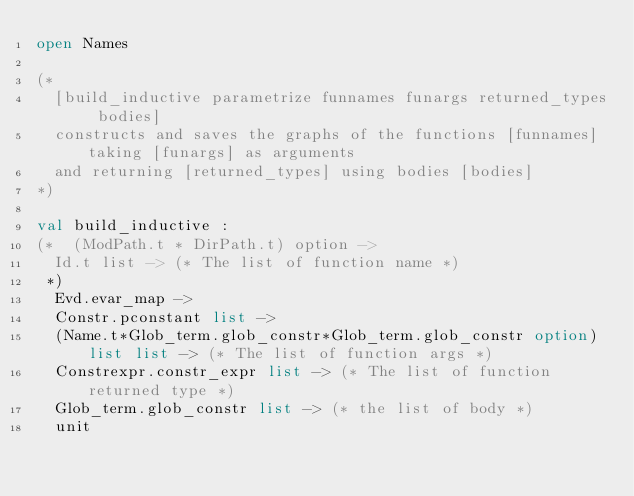<code> <loc_0><loc_0><loc_500><loc_500><_OCaml_>open Names

(*
  [build_inductive parametrize funnames funargs returned_types bodies]
  constructs and saves the graphs of the functions [funnames] taking [funargs] as arguments
  and returning [returned_types] using bodies [bodies]
*)

val build_inductive :
(*  (ModPath.t * DirPath.t) option ->
  Id.t list -> (* The list of function name *) 
 *)
  Evd.evar_map ->
  Constr.pconstant list -> 
  (Name.t*Glob_term.glob_constr*Glob_term.glob_constr option) list list -> (* The list of function args *)
  Constrexpr.constr_expr list -> (* The list of function returned type *)
  Glob_term.glob_constr list -> (* the list of body *)
  unit

</code> 